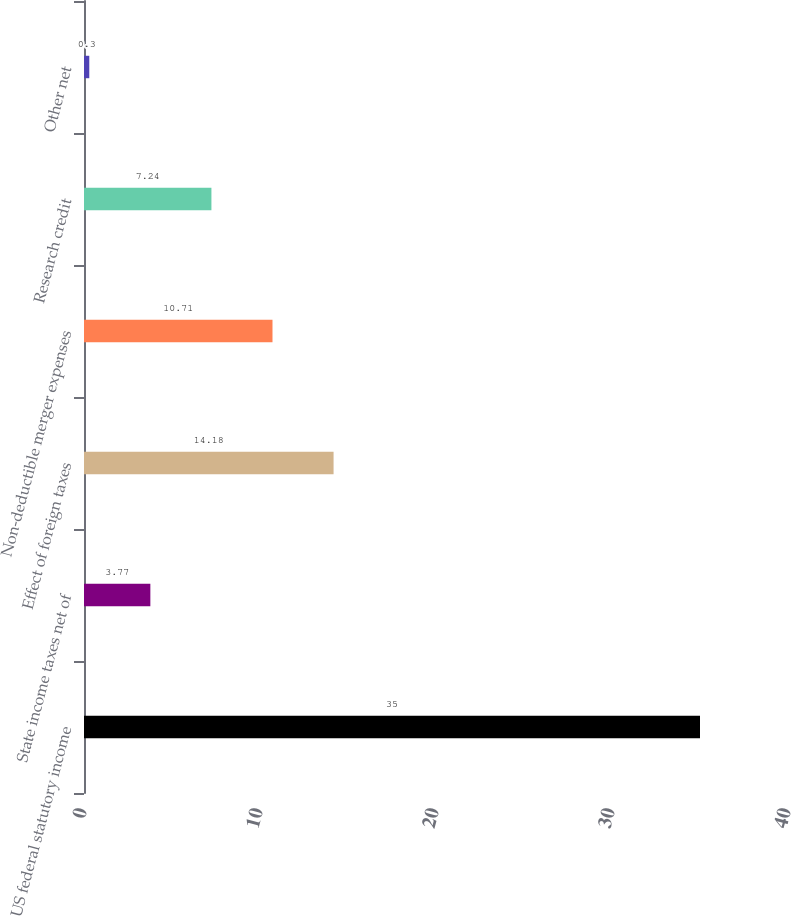<chart> <loc_0><loc_0><loc_500><loc_500><bar_chart><fcel>US federal statutory income<fcel>State income taxes net of<fcel>Effect of foreign taxes<fcel>Non-deductible merger expenses<fcel>Research credit<fcel>Other net<nl><fcel>35<fcel>3.77<fcel>14.18<fcel>10.71<fcel>7.24<fcel>0.3<nl></chart> 